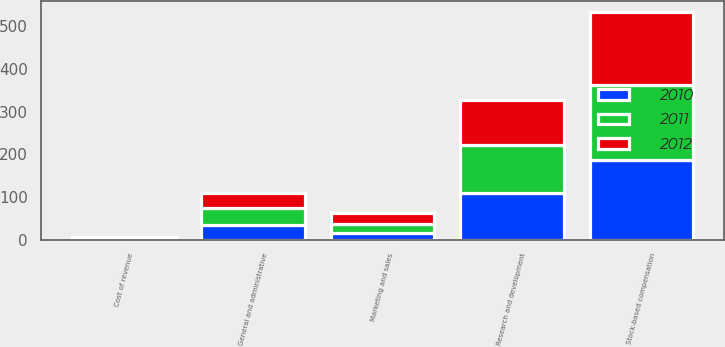Convert chart. <chart><loc_0><loc_0><loc_500><loc_500><stacked_bar_chart><ecel><fcel>Cost of revenue<fcel>Marketing and sales<fcel>General and administrative<fcel>Research and development<fcel>Stock-based compensation<nl><fcel>2012<fcel>2<fcel>26<fcel>36<fcel>106<fcel>170<nl><fcel>2011<fcel>2<fcel>21<fcel>40<fcel>111<fcel>176<nl><fcel>2010<fcel>2<fcel>16<fcel>33<fcel>110<fcel>187<nl></chart> 